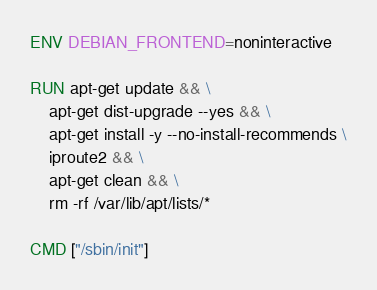Convert code to text. <code><loc_0><loc_0><loc_500><loc_500><_Dockerfile_>ENV DEBIAN_FRONTEND=noninteractive

RUN apt-get update && \
	apt-get dist-upgrade --yes && \
    apt-get install -y --no-install-recommends \
    iproute2 && \
    apt-get clean && \
    rm -rf /var/lib/apt/lists/*

CMD ["/sbin/init"]
</code> 